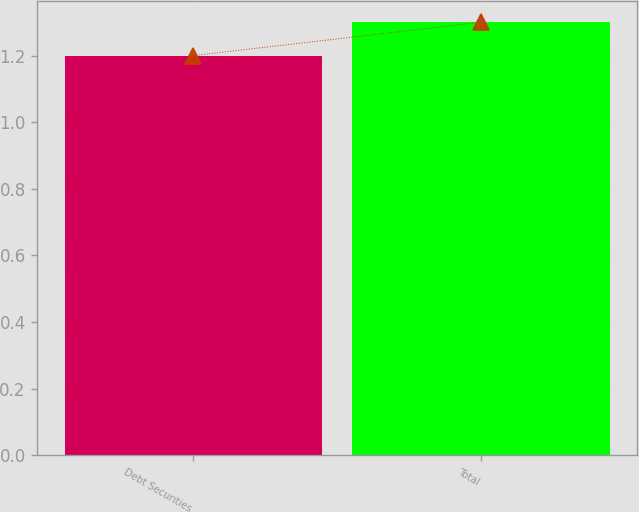Convert chart. <chart><loc_0><loc_0><loc_500><loc_500><bar_chart><fcel>Debt Securities<fcel>Total<nl><fcel>1.2<fcel>1.3<nl></chart> 